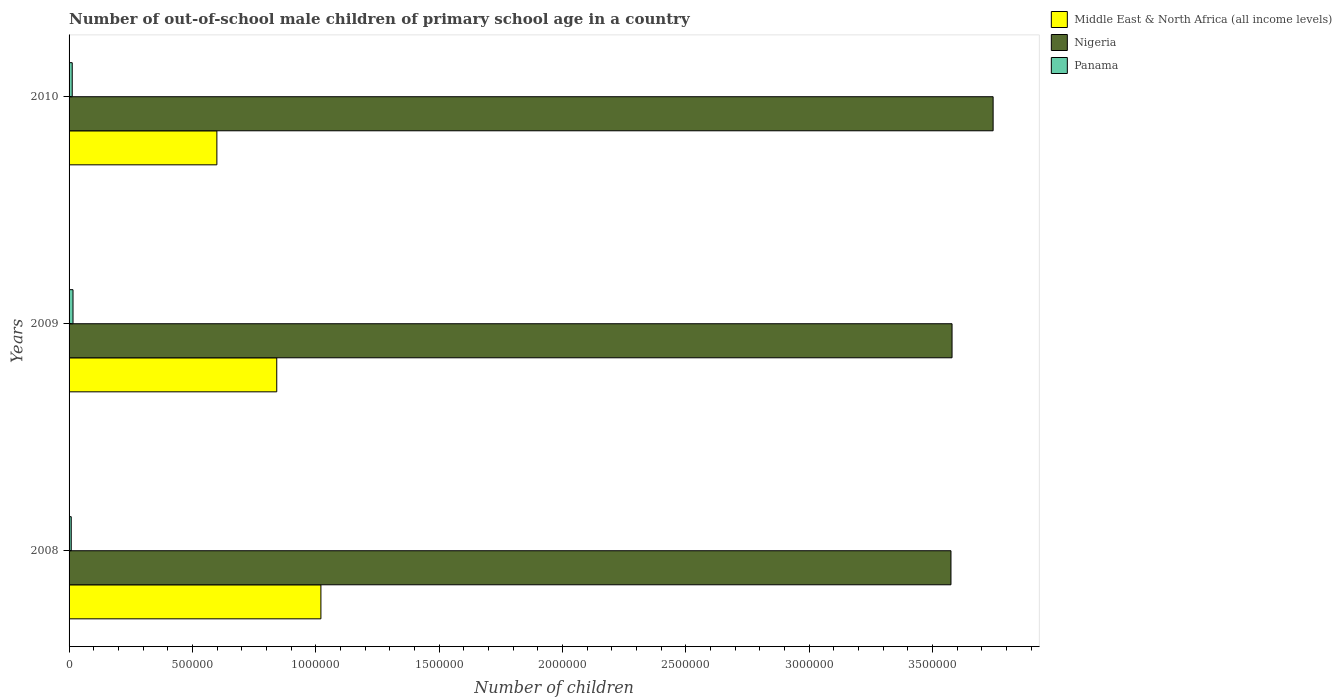How many bars are there on the 2nd tick from the top?
Ensure brevity in your answer.  3. What is the label of the 1st group of bars from the top?
Your answer should be very brief. 2010. What is the number of out-of-school male children in Middle East & North Africa (all income levels) in 2010?
Your answer should be compact. 5.99e+05. Across all years, what is the maximum number of out-of-school male children in Middle East & North Africa (all income levels)?
Ensure brevity in your answer.  1.02e+06. Across all years, what is the minimum number of out-of-school male children in Middle East & North Africa (all income levels)?
Give a very brief answer. 5.99e+05. What is the total number of out-of-school male children in Nigeria in the graph?
Make the answer very short. 1.09e+07. What is the difference between the number of out-of-school male children in Panama in 2008 and that in 2009?
Provide a succinct answer. -7177. What is the difference between the number of out-of-school male children in Middle East & North Africa (all income levels) in 2010 and the number of out-of-school male children in Nigeria in 2008?
Your response must be concise. -2.98e+06. What is the average number of out-of-school male children in Panama per year?
Offer a terse response. 1.25e+04. In the year 2009, what is the difference between the number of out-of-school male children in Nigeria and number of out-of-school male children in Middle East & North Africa (all income levels)?
Make the answer very short. 2.74e+06. In how many years, is the number of out-of-school male children in Panama greater than 1200000 ?
Offer a terse response. 0. What is the ratio of the number of out-of-school male children in Nigeria in 2008 to that in 2009?
Your answer should be compact. 1. What is the difference between the highest and the second highest number of out-of-school male children in Middle East & North Africa (all income levels)?
Your answer should be compact. 1.79e+05. What is the difference between the highest and the lowest number of out-of-school male children in Nigeria?
Give a very brief answer. 1.71e+05. In how many years, is the number of out-of-school male children in Middle East & North Africa (all income levels) greater than the average number of out-of-school male children in Middle East & North Africa (all income levels) taken over all years?
Make the answer very short. 2. Is the sum of the number of out-of-school male children in Panama in 2008 and 2010 greater than the maximum number of out-of-school male children in Nigeria across all years?
Give a very brief answer. No. What does the 1st bar from the top in 2008 represents?
Give a very brief answer. Panama. What does the 3rd bar from the bottom in 2008 represents?
Ensure brevity in your answer.  Panama. Is it the case that in every year, the sum of the number of out-of-school male children in Panama and number of out-of-school male children in Nigeria is greater than the number of out-of-school male children in Middle East & North Africa (all income levels)?
Your answer should be compact. Yes. How many bars are there?
Provide a short and direct response. 9. What is the difference between two consecutive major ticks on the X-axis?
Offer a very short reply. 5.00e+05. Are the values on the major ticks of X-axis written in scientific E-notation?
Provide a short and direct response. No. Does the graph contain any zero values?
Offer a terse response. No. Where does the legend appear in the graph?
Give a very brief answer. Top right. What is the title of the graph?
Your answer should be very brief. Number of out-of-school male children of primary school age in a country. What is the label or title of the X-axis?
Keep it short and to the point. Number of children. What is the label or title of the Y-axis?
Offer a terse response. Years. What is the Number of children in Middle East & North Africa (all income levels) in 2008?
Your answer should be very brief. 1.02e+06. What is the Number of children of Nigeria in 2008?
Ensure brevity in your answer.  3.57e+06. What is the Number of children of Panama in 2008?
Make the answer very short. 8786. What is the Number of children of Middle East & North Africa (all income levels) in 2009?
Your response must be concise. 8.42e+05. What is the Number of children of Nigeria in 2009?
Keep it short and to the point. 3.58e+06. What is the Number of children of Panama in 2009?
Keep it short and to the point. 1.60e+04. What is the Number of children in Middle East & North Africa (all income levels) in 2010?
Offer a terse response. 5.99e+05. What is the Number of children of Nigeria in 2010?
Make the answer very short. 3.75e+06. What is the Number of children of Panama in 2010?
Keep it short and to the point. 1.28e+04. Across all years, what is the maximum Number of children of Middle East & North Africa (all income levels)?
Your answer should be compact. 1.02e+06. Across all years, what is the maximum Number of children in Nigeria?
Make the answer very short. 3.75e+06. Across all years, what is the maximum Number of children of Panama?
Make the answer very short. 1.60e+04. Across all years, what is the minimum Number of children of Middle East & North Africa (all income levels)?
Ensure brevity in your answer.  5.99e+05. Across all years, what is the minimum Number of children of Nigeria?
Offer a very short reply. 3.57e+06. Across all years, what is the minimum Number of children of Panama?
Offer a terse response. 8786. What is the total Number of children in Middle East & North Africa (all income levels) in the graph?
Your response must be concise. 2.46e+06. What is the total Number of children in Nigeria in the graph?
Your response must be concise. 1.09e+07. What is the total Number of children of Panama in the graph?
Ensure brevity in your answer.  3.76e+04. What is the difference between the Number of children of Middle East & North Africa (all income levels) in 2008 and that in 2009?
Provide a succinct answer. 1.79e+05. What is the difference between the Number of children in Nigeria in 2008 and that in 2009?
Your answer should be very brief. -4340. What is the difference between the Number of children in Panama in 2008 and that in 2009?
Offer a very short reply. -7177. What is the difference between the Number of children in Middle East & North Africa (all income levels) in 2008 and that in 2010?
Provide a short and direct response. 4.22e+05. What is the difference between the Number of children of Nigeria in 2008 and that in 2010?
Your answer should be compact. -1.71e+05. What is the difference between the Number of children of Panama in 2008 and that in 2010?
Your answer should be very brief. -4018. What is the difference between the Number of children in Middle East & North Africa (all income levels) in 2009 and that in 2010?
Your answer should be compact. 2.43e+05. What is the difference between the Number of children of Nigeria in 2009 and that in 2010?
Ensure brevity in your answer.  -1.66e+05. What is the difference between the Number of children in Panama in 2009 and that in 2010?
Provide a succinct answer. 3159. What is the difference between the Number of children of Middle East & North Africa (all income levels) in 2008 and the Number of children of Nigeria in 2009?
Ensure brevity in your answer.  -2.56e+06. What is the difference between the Number of children in Middle East & North Africa (all income levels) in 2008 and the Number of children in Panama in 2009?
Keep it short and to the point. 1.00e+06. What is the difference between the Number of children of Nigeria in 2008 and the Number of children of Panama in 2009?
Keep it short and to the point. 3.56e+06. What is the difference between the Number of children in Middle East & North Africa (all income levels) in 2008 and the Number of children in Nigeria in 2010?
Your answer should be compact. -2.72e+06. What is the difference between the Number of children of Middle East & North Africa (all income levels) in 2008 and the Number of children of Panama in 2010?
Offer a terse response. 1.01e+06. What is the difference between the Number of children of Nigeria in 2008 and the Number of children of Panama in 2010?
Your answer should be very brief. 3.56e+06. What is the difference between the Number of children in Middle East & North Africa (all income levels) in 2009 and the Number of children in Nigeria in 2010?
Offer a very short reply. -2.90e+06. What is the difference between the Number of children in Middle East & North Africa (all income levels) in 2009 and the Number of children in Panama in 2010?
Keep it short and to the point. 8.29e+05. What is the difference between the Number of children of Nigeria in 2009 and the Number of children of Panama in 2010?
Give a very brief answer. 3.57e+06. What is the average Number of children of Middle East & North Africa (all income levels) per year?
Keep it short and to the point. 8.21e+05. What is the average Number of children in Nigeria per year?
Offer a terse response. 3.63e+06. What is the average Number of children in Panama per year?
Ensure brevity in your answer.  1.25e+04. In the year 2008, what is the difference between the Number of children of Middle East & North Africa (all income levels) and Number of children of Nigeria?
Offer a terse response. -2.55e+06. In the year 2008, what is the difference between the Number of children in Middle East & North Africa (all income levels) and Number of children in Panama?
Your answer should be compact. 1.01e+06. In the year 2008, what is the difference between the Number of children in Nigeria and Number of children in Panama?
Your answer should be compact. 3.57e+06. In the year 2009, what is the difference between the Number of children in Middle East & North Africa (all income levels) and Number of children in Nigeria?
Your answer should be very brief. -2.74e+06. In the year 2009, what is the difference between the Number of children of Middle East & North Africa (all income levels) and Number of children of Panama?
Offer a terse response. 8.26e+05. In the year 2009, what is the difference between the Number of children of Nigeria and Number of children of Panama?
Offer a very short reply. 3.56e+06. In the year 2010, what is the difference between the Number of children of Middle East & North Africa (all income levels) and Number of children of Nigeria?
Your answer should be very brief. -3.15e+06. In the year 2010, what is the difference between the Number of children in Middle East & North Africa (all income levels) and Number of children in Panama?
Ensure brevity in your answer.  5.86e+05. In the year 2010, what is the difference between the Number of children of Nigeria and Number of children of Panama?
Provide a succinct answer. 3.73e+06. What is the ratio of the Number of children in Middle East & North Africa (all income levels) in 2008 to that in 2009?
Offer a very short reply. 1.21. What is the ratio of the Number of children in Panama in 2008 to that in 2009?
Offer a very short reply. 0.55. What is the ratio of the Number of children of Middle East & North Africa (all income levels) in 2008 to that in 2010?
Ensure brevity in your answer.  1.7. What is the ratio of the Number of children of Nigeria in 2008 to that in 2010?
Make the answer very short. 0.95. What is the ratio of the Number of children in Panama in 2008 to that in 2010?
Your answer should be compact. 0.69. What is the ratio of the Number of children of Middle East & North Africa (all income levels) in 2009 to that in 2010?
Ensure brevity in your answer.  1.41. What is the ratio of the Number of children of Nigeria in 2009 to that in 2010?
Provide a succinct answer. 0.96. What is the ratio of the Number of children of Panama in 2009 to that in 2010?
Offer a very short reply. 1.25. What is the difference between the highest and the second highest Number of children in Middle East & North Africa (all income levels)?
Your answer should be very brief. 1.79e+05. What is the difference between the highest and the second highest Number of children in Nigeria?
Give a very brief answer. 1.66e+05. What is the difference between the highest and the second highest Number of children of Panama?
Ensure brevity in your answer.  3159. What is the difference between the highest and the lowest Number of children of Middle East & North Africa (all income levels)?
Give a very brief answer. 4.22e+05. What is the difference between the highest and the lowest Number of children in Nigeria?
Offer a very short reply. 1.71e+05. What is the difference between the highest and the lowest Number of children in Panama?
Offer a terse response. 7177. 